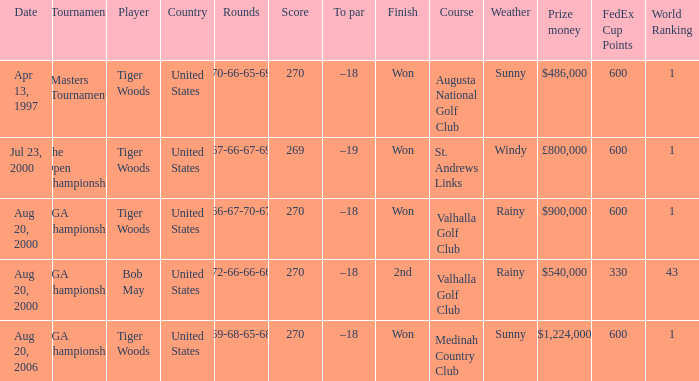What is the worst (highest) score? 270.0. 